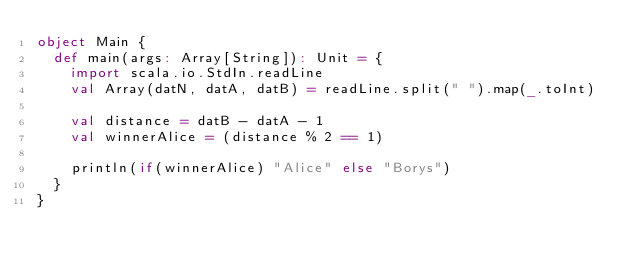Convert code to text. <code><loc_0><loc_0><loc_500><loc_500><_Scala_>object Main {
  def main(args: Array[String]): Unit = {
    import scala.io.StdIn.readLine
    val Array(datN, datA, datB) = readLine.split(" ").map(_.toInt)

    val distance = datB - datA - 1
    val winnerAlice = (distance % 2 == 1)

    println(if(winnerAlice) "Alice" else "Borys")
  }
}
</code> 